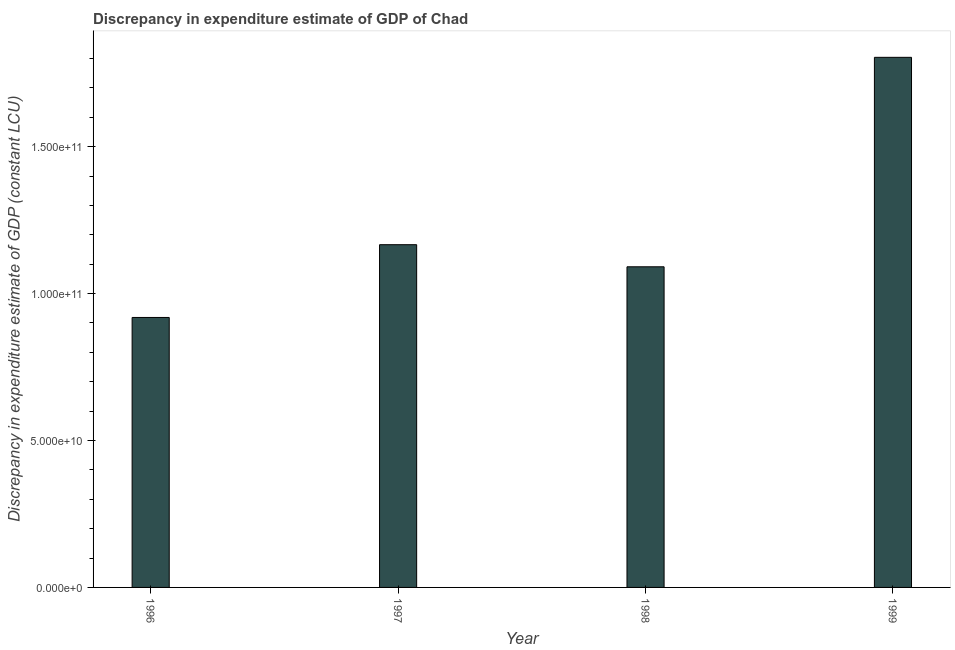Does the graph contain grids?
Keep it short and to the point. No. What is the title of the graph?
Your answer should be very brief. Discrepancy in expenditure estimate of GDP of Chad. What is the label or title of the Y-axis?
Provide a succinct answer. Discrepancy in expenditure estimate of GDP (constant LCU). What is the discrepancy in expenditure estimate of gdp in 1999?
Give a very brief answer. 1.80e+11. Across all years, what is the maximum discrepancy in expenditure estimate of gdp?
Provide a succinct answer. 1.80e+11. Across all years, what is the minimum discrepancy in expenditure estimate of gdp?
Your answer should be very brief. 9.19e+1. What is the sum of the discrepancy in expenditure estimate of gdp?
Make the answer very short. 4.98e+11. What is the difference between the discrepancy in expenditure estimate of gdp in 1996 and 1997?
Your answer should be very brief. -2.48e+1. What is the average discrepancy in expenditure estimate of gdp per year?
Your answer should be compact. 1.25e+11. What is the median discrepancy in expenditure estimate of gdp?
Your response must be concise. 1.13e+11. In how many years, is the discrepancy in expenditure estimate of gdp greater than 80000000000 LCU?
Your response must be concise. 4. What is the ratio of the discrepancy in expenditure estimate of gdp in 1996 to that in 1997?
Your response must be concise. 0.79. Is the discrepancy in expenditure estimate of gdp in 1997 less than that in 1999?
Make the answer very short. Yes. What is the difference between the highest and the second highest discrepancy in expenditure estimate of gdp?
Your answer should be very brief. 6.38e+1. What is the difference between the highest and the lowest discrepancy in expenditure estimate of gdp?
Offer a terse response. 8.85e+1. In how many years, is the discrepancy in expenditure estimate of gdp greater than the average discrepancy in expenditure estimate of gdp taken over all years?
Provide a succinct answer. 1. How many bars are there?
Give a very brief answer. 4. Are all the bars in the graph horizontal?
Your answer should be very brief. No. What is the Discrepancy in expenditure estimate of GDP (constant LCU) in 1996?
Provide a succinct answer. 9.19e+1. What is the Discrepancy in expenditure estimate of GDP (constant LCU) in 1997?
Offer a terse response. 1.17e+11. What is the Discrepancy in expenditure estimate of GDP (constant LCU) of 1998?
Give a very brief answer. 1.09e+11. What is the Discrepancy in expenditure estimate of GDP (constant LCU) of 1999?
Make the answer very short. 1.80e+11. What is the difference between the Discrepancy in expenditure estimate of GDP (constant LCU) in 1996 and 1997?
Provide a short and direct response. -2.48e+1. What is the difference between the Discrepancy in expenditure estimate of GDP (constant LCU) in 1996 and 1998?
Your answer should be very brief. -1.72e+1. What is the difference between the Discrepancy in expenditure estimate of GDP (constant LCU) in 1996 and 1999?
Provide a succinct answer. -8.85e+1. What is the difference between the Discrepancy in expenditure estimate of GDP (constant LCU) in 1997 and 1998?
Your answer should be compact. 7.52e+09. What is the difference between the Discrepancy in expenditure estimate of GDP (constant LCU) in 1997 and 1999?
Your answer should be very brief. -6.38e+1. What is the difference between the Discrepancy in expenditure estimate of GDP (constant LCU) in 1998 and 1999?
Provide a succinct answer. -7.13e+1. What is the ratio of the Discrepancy in expenditure estimate of GDP (constant LCU) in 1996 to that in 1997?
Your answer should be very brief. 0.79. What is the ratio of the Discrepancy in expenditure estimate of GDP (constant LCU) in 1996 to that in 1998?
Give a very brief answer. 0.84. What is the ratio of the Discrepancy in expenditure estimate of GDP (constant LCU) in 1996 to that in 1999?
Ensure brevity in your answer.  0.51. What is the ratio of the Discrepancy in expenditure estimate of GDP (constant LCU) in 1997 to that in 1998?
Give a very brief answer. 1.07. What is the ratio of the Discrepancy in expenditure estimate of GDP (constant LCU) in 1997 to that in 1999?
Provide a short and direct response. 0.65. What is the ratio of the Discrepancy in expenditure estimate of GDP (constant LCU) in 1998 to that in 1999?
Provide a short and direct response. 0.6. 